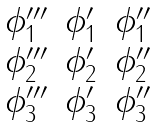Convert formula to latex. <formula><loc_0><loc_0><loc_500><loc_500>\begin{matrix} \phi _ { 1 } ^ { \prime \prime \prime } & \phi _ { 1 } ^ { \prime } & \phi _ { 1 } ^ { \prime \prime } \\ \phi _ { 2 } ^ { \prime \prime \prime } & \phi _ { 2 } ^ { \prime } & \phi _ { 2 } ^ { \prime \prime } \\ \phi _ { 3 } ^ { \prime \prime \prime } & \phi _ { 3 } ^ { \prime } & \phi _ { 3 } ^ { \prime \prime } \end{matrix}</formula> 